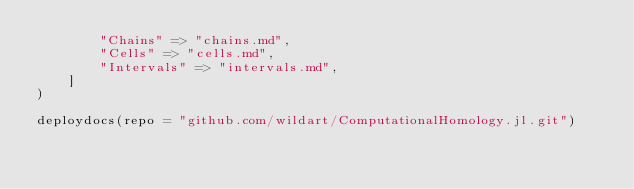<code> <loc_0><loc_0><loc_500><loc_500><_Julia_>        "Chains" => "chains.md",
        "Cells" => "cells.md",
        "Intervals" => "intervals.md",
    ]
)

deploydocs(repo = "github.com/wildart/ComputationalHomology.jl.git")
</code> 